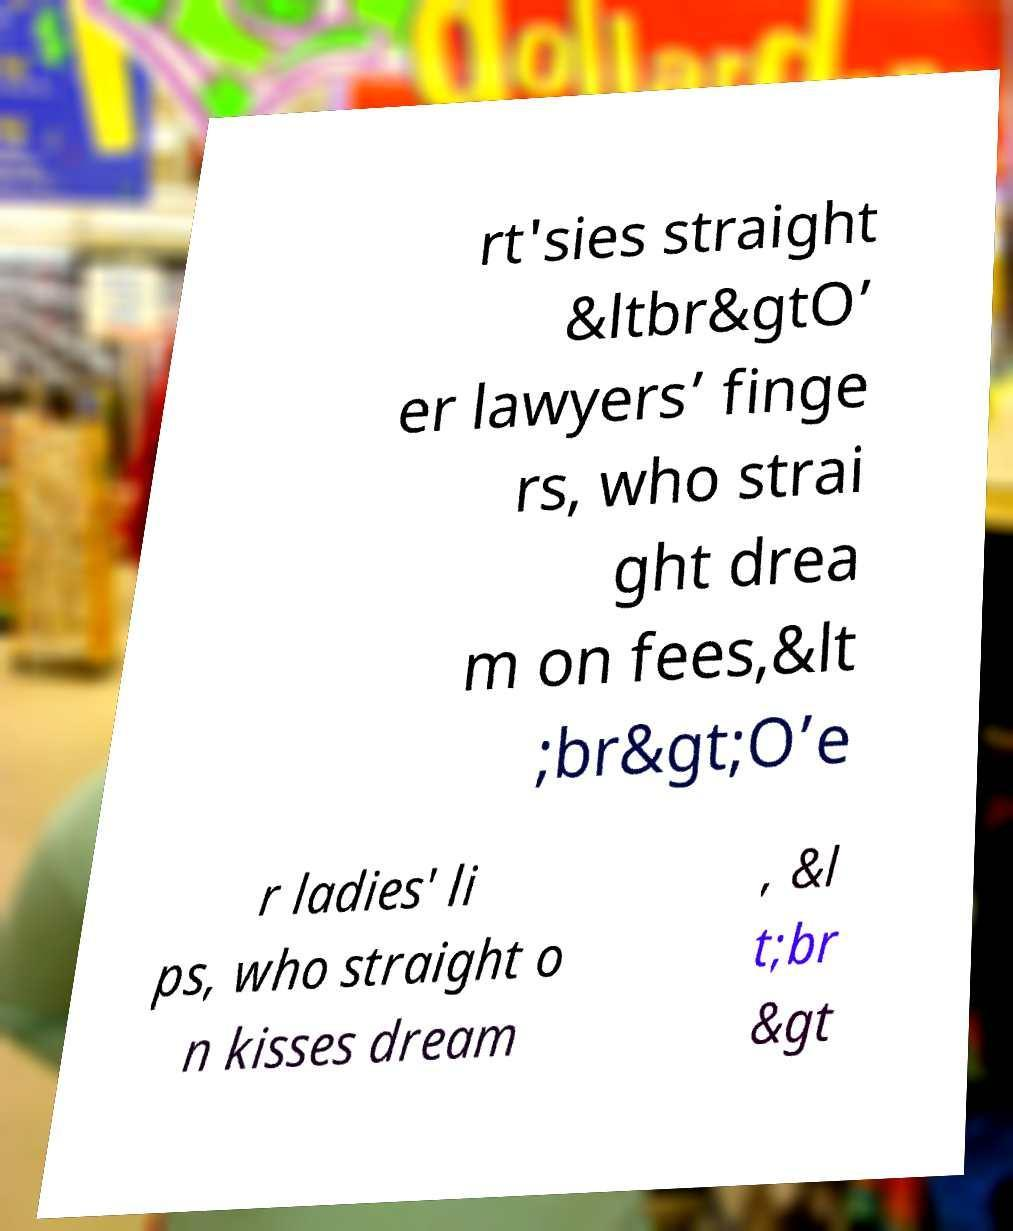Can you read and provide the text displayed in the image?This photo seems to have some interesting text. Can you extract and type it out for me? rt'sies straight &ltbr&gtO’ er lawyers’ finge rs, who strai ght drea m on fees,&lt ;br&gt;O’e r ladies' li ps, who straight o n kisses dream , &l t;br &gt 